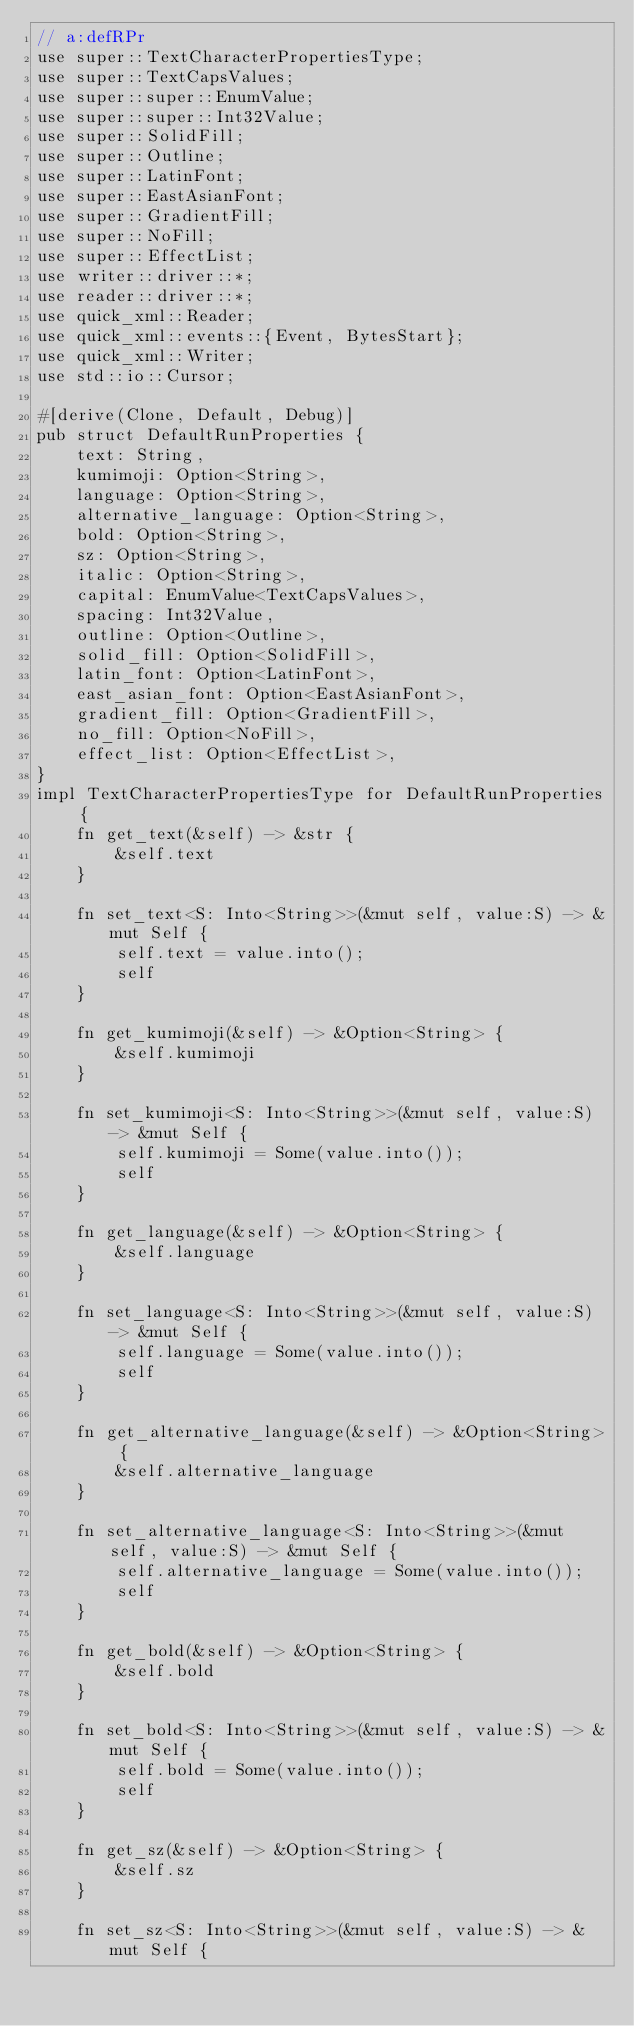Convert code to text. <code><loc_0><loc_0><loc_500><loc_500><_Rust_>// a:defRPr
use super::TextCharacterPropertiesType;
use super::TextCapsValues;
use super::super::EnumValue;
use super::super::Int32Value;
use super::SolidFill;
use super::Outline;
use super::LatinFont;
use super::EastAsianFont;
use super::GradientFill;
use super::NoFill;
use super::EffectList;
use writer::driver::*;
use reader::driver::*;
use quick_xml::Reader;
use quick_xml::events::{Event, BytesStart};
use quick_xml::Writer;
use std::io::Cursor;

#[derive(Clone, Default, Debug)]
pub struct DefaultRunProperties {
    text: String,
    kumimoji: Option<String>,
    language: Option<String>,
    alternative_language: Option<String>,
    bold: Option<String>,
    sz: Option<String>,
    italic: Option<String>,
    capital: EnumValue<TextCapsValues>,
    spacing: Int32Value,
    outline: Option<Outline>,
    solid_fill: Option<SolidFill>,
    latin_font: Option<LatinFont>,
    east_asian_font: Option<EastAsianFont>,
    gradient_fill: Option<GradientFill>,
    no_fill: Option<NoFill>,
    effect_list: Option<EffectList>,
}
impl TextCharacterPropertiesType for DefaultRunProperties {
    fn get_text(&self) -> &str {
        &self.text
    }

    fn set_text<S: Into<String>>(&mut self, value:S) -> &mut Self {
        self.text = value.into();
        self
    }

    fn get_kumimoji(&self) -> &Option<String> {
        &self.kumimoji
    }

    fn set_kumimoji<S: Into<String>>(&mut self, value:S) -> &mut Self {
        self.kumimoji = Some(value.into());
        self
    }

    fn get_language(&self) -> &Option<String> {
        &self.language
    }

    fn set_language<S: Into<String>>(&mut self, value:S) -> &mut Self {
        self.language = Some(value.into());
        self
    }

    fn get_alternative_language(&self) -> &Option<String> {
        &self.alternative_language
    }

    fn set_alternative_language<S: Into<String>>(&mut self, value:S) -> &mut Self {
        self.alternative_language = Some(value.into());
        self
    }

    fn get_bold(&self) -> &Option<String> {
        &self.bold
    }

    fn set_bold<S: Into<String>>(&mut self, value:S) -> &mut Self {
        self.bold = Some(value.into());
        self
    }

    fn get_sz(&self) -> &Option<String> {
        &self.sz
    }

    fn set_sz<S: Into<String>>(&mut self, value:S) -> &mut Self {</code> 